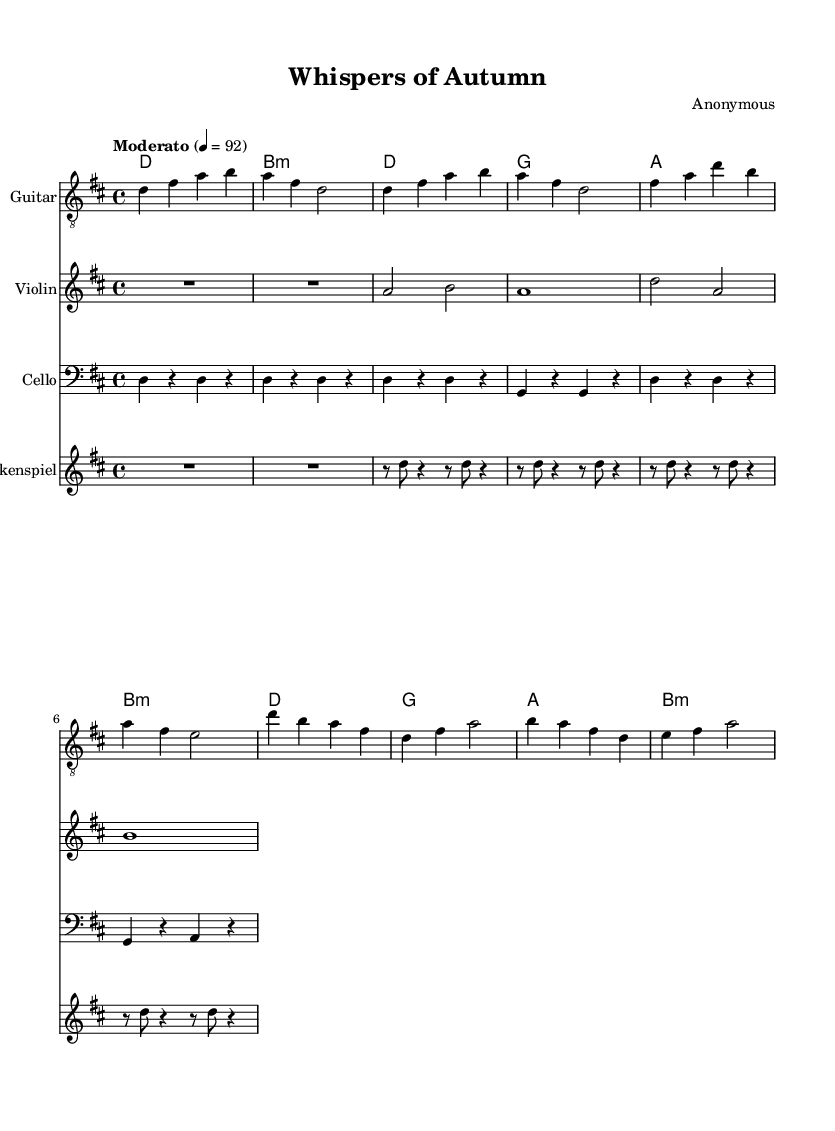what is the key signature of this music? The key signature is indicated in the global context at the beginning of the score, where it specifies "d major," which has two sharps (F# and C#).
Answer: D major what is the time signature of this music? The time signature is also found in the global section, where it specifies "4/4," meaning there are four quarter-note beats in each measure.
Answer: 4/4 what is the tempo marking of this music? The tempo marking is presented in the global section as "Moderato," and later it gives the tempo indication as "4 = 92," indicating a moderate speed.
Answer: Moderato how many measures are in the chorus section? To determine the number of measures in the chorus, we count the measures specified under the chorus section of each instrument. There are four measures in total (d'4 b a fis d fis a2 and so on).
Answer: 4 which instrument plays the lowest pitches in this sheet music? By evaluating the notated pitches, the cello part predominantly contains the lowest pitches, as it is written in the bass clef and plays lower notes than the other instruments.
Answer: Cello what is the chord sequence used in the verse? The chord sequence for the verse can be observed from the chord names provided below the notation, consisting of d, g, a, and b:m.
Answer: D, G, A, B minor what role does the glockenspiel play in this piece? The glockenspiel provides a higher melodic line and embellishes the texture of the music. It plays rhythmic patterns that complement the harmony, evident from the repeated rhythmic figures in its part.
Answer: Melodic embellishment 